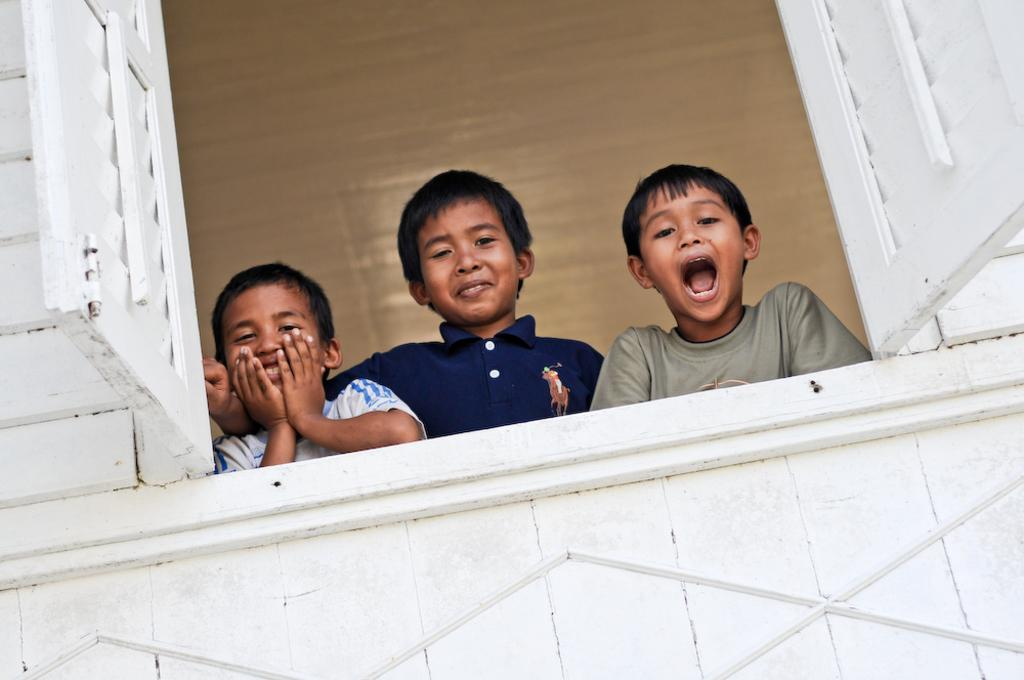What can be seen on a part of the building in the image? There is a window in the image, which is on a wall. Who or what can be seen behind the window? Three children are visible behind the window. What is the facial expression of the children? The children are smiling. What might the children be doing behind the window? The children are posing for a picture. What type of sweater is the nation wearing in the image? There is no nation or sweater present in the image; it features a window with children behind it. How are the children sorting themselves in the image? The children are not sorting themselves in the image; they are posing for a picture with smiles on their faces. 